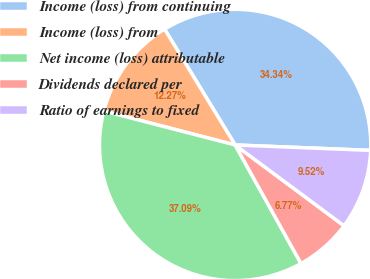<chart> <loc_0><loc_0><loc_500><loc_500><pie_chart><fcel>Income (loss) from continuing<fcel>Income (loss) from<fcel>Net income (loss) attributable<fcel>Dividends declared per<fcel>Ratio of earnings to fixed<nl><fcel>34.34%<fcel>12.27%<fcel>37.09%<fcel>6.77%<fcel>9.52%<nl></chart> 